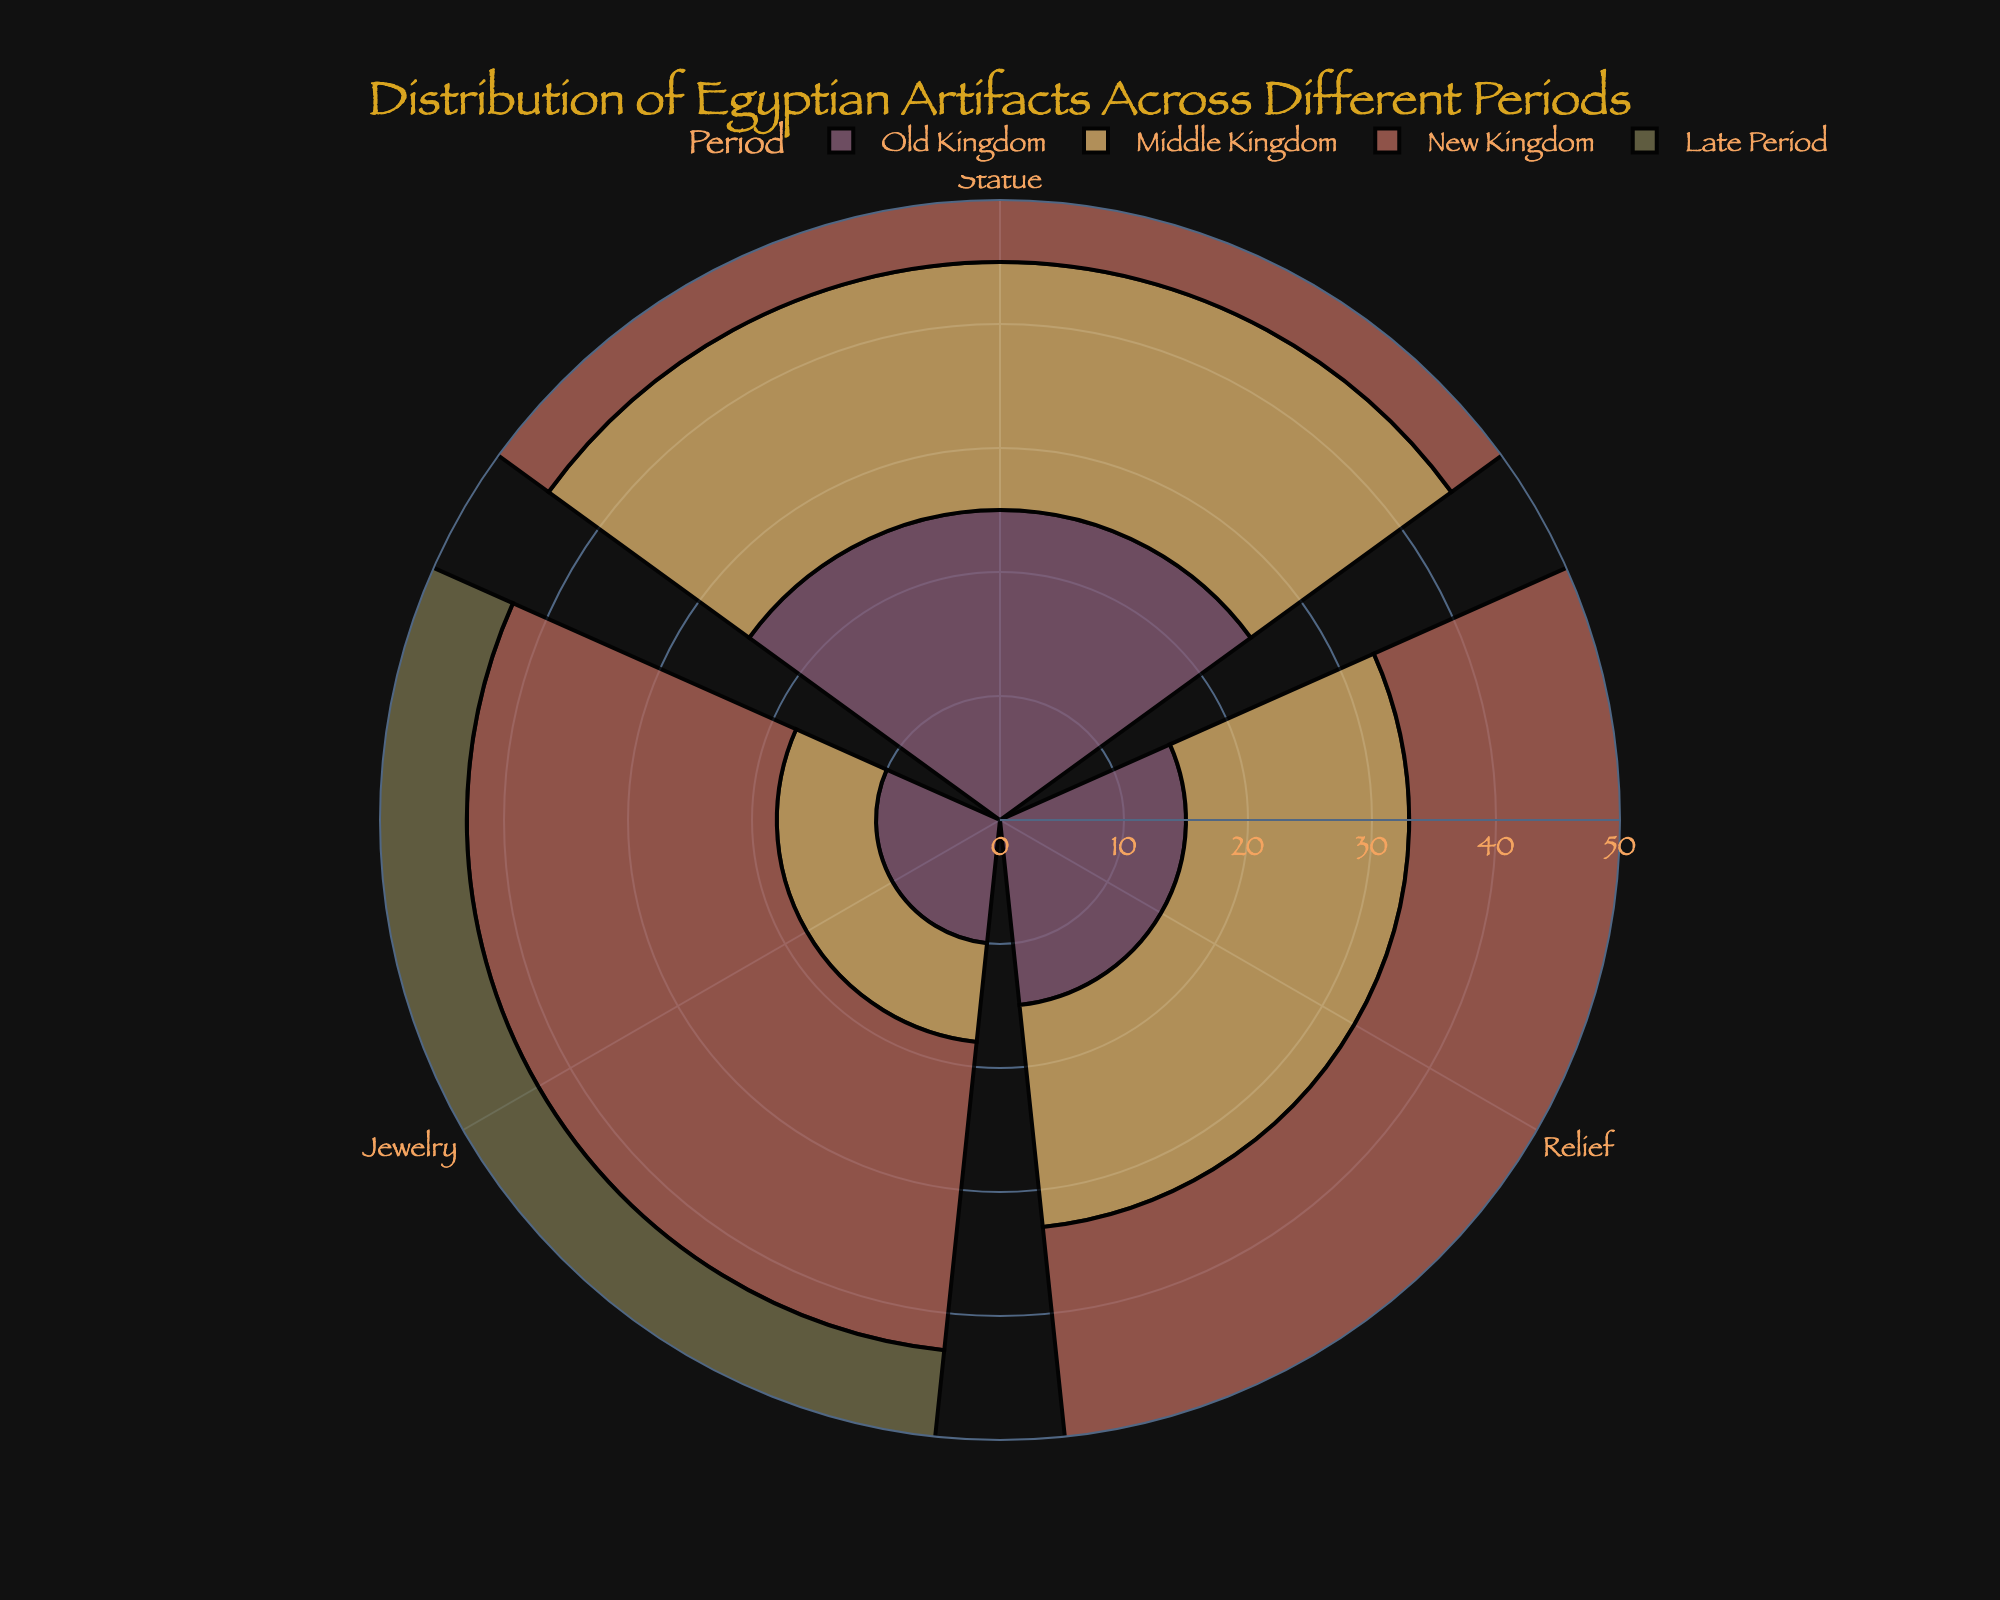What is the title of the chart? The title is typically found at the top-center of the figure and in this case, it clearly states what the chart is about.
Answer: Distribution of Egyptian Artifacts Across Different Periods Which artifact type has the highest quantity in the New Kingdom? By looking at the section for the New Kingdom, the lengths of the bars indicate the quantities, and the longest bar corresponds to the Relief artifact type.
Answer: Relief How many statues are there in total across all periods? To find the total count of statues, sum the quantities for statues from each period: 25 (Old Kingdom) + 20 (Middle Kingdom) + 30 (New Kingdom) + 12 (Late Period).
Answer: 87 Which period has the most diverse types of artifacts? The diversity can be inferred from the number of different artifact types present in each period’s section. Each period's section with different colored segments represents different types of artifacts.
Answer: All periods have three types of artifacts Which period has the lowest quantity of Jewelry artifacts? By comparing the lengths of the Jewelry bars in each period’s segment, the shortest one indicates the period with the least amount.
Answer: Middle Kingdom Are there more Relief artifacts in the Middle Kingdom or the Late Period? Compare the length of the Relief bars in the Middle Kingdom and Late Period sections. The bar for the Late Period is longer.
Answer: Late Period What is the range of quantities for artifacts in the New Kingdom? To determine the range, look at the New Kingdom section and identify the minimum and maximum quantities: 25 (Jewelry) to 40 (Relief). Range is calculated as maximum - minimum.
Answer: 15 How does the quantity of Relief artifacts in the Old Kingdom compare to that in the Middle Kingdom? Compare the lengths of the bars for Relief artifacts in both periods. The bar in the Middle Kingdom section is longer.
Answer: Middle Kingdom has more What's the total quantity of artifacts in the Late Period? Sum the quantities for all artifact types in the Late Period: 12 (Statue) + 22 (Relief) + 15 (Jewelry).
Answer: 49 Which period shows an equal quantity of Jewelry and Statue artifacts? Look for periods where the bars for Jewelry and Statue artifacts are of equal length. Visual inspection shows Old Kingdom as having different lengths, so check others.
Answer: None 